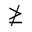<formula> <loc_0><loc_0><loc_500><loc_500>\ngeq</formula> 